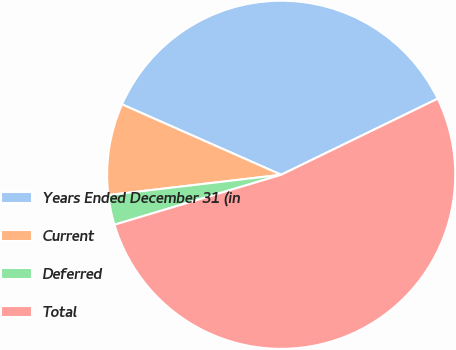<chart> <loc_0><loc_0><loc_500><loc_500><pie_chart><fcel>Years Ended December 31 (in<fcel>Current<fcel>Deferred<fcel>Total<nl><fcel>36.17%<fcel>8.49%<fcel>2.77%<fcel>52.57%<nl></chart> 